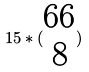<formula> <loc_0><loc_0><loc_500><loc_500>1 5 * ( \begin{matrix} 6 6 \\ 8 \end{matrix} )</formula> 